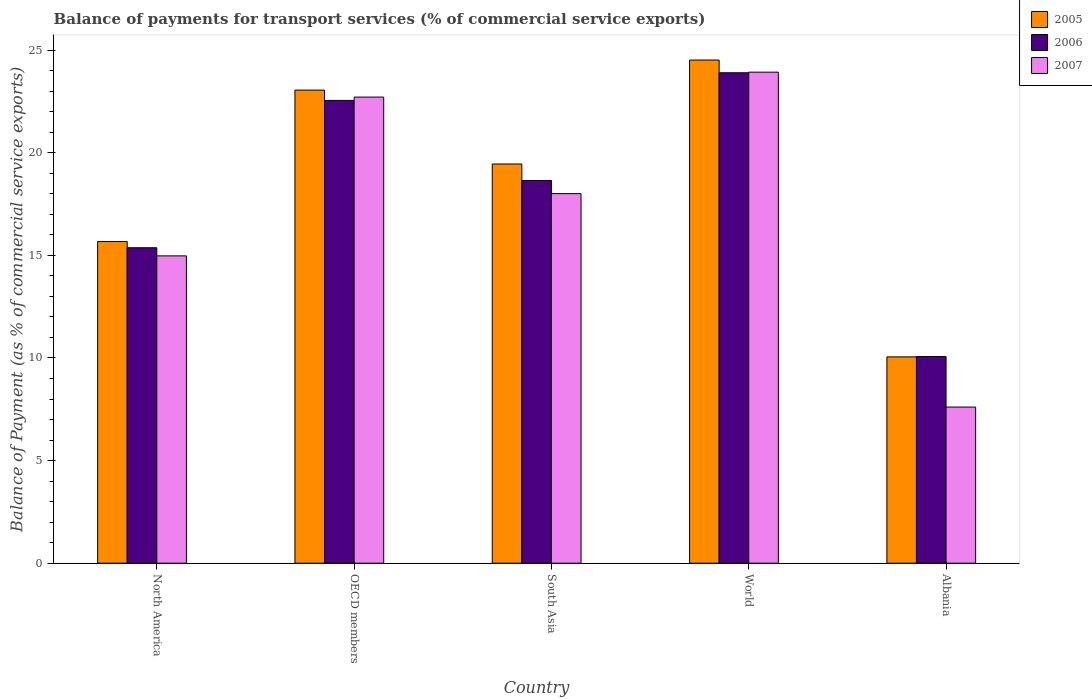Are the number of bars per tick equal to the number of legend labels?
Give a very brief answer. Yes. Are the number of bars on each tick of the X-axis equal?
Give a very brief answer. Yes. How many bars are there on the 3rd tick from the right?
Offer a very short reply. 3. In how many cases, is the number of bars for a given country not equal to the number of legend labels?
Keep it short and to the point. 0. What is the balance of payments for transport services in 2006 in Albania?
Ensure brevity in your answer.  10.07. Across all countries, what is the maximum balance of payments for transport services in 2005?
Provide a succinct answer. 24.52. Across all countries, what is the minimum balance of payments for transport services in 2006?
Your answer should be compact. 10.07. In which country was the balance of payments for transport services in 2007 maximum?
Give a very brief answer. World. In which country was the balance of payments for transport services in 2005 minimum?
Ensure brevity in your answer.  Albania. What is the total balance of payments for transport services in 2005 in the graph?
Keep it short and to the point. 92.75. What is the difference between the balance of payments for transport services in 2005 in North America and that in World?
Provide a succinct answer. -8.84. What is the difference between the balance of payments for transport services in 2006 in World and the balance of payments for transport services in 2007 in Albania?
Provide a succinct answer. 16.29. What is the average balance of payments for transport services in 2006 per country?
Offer a terse response. 18.11. What is the difference between the balance of payments for transport services of/in 2005 and balance of payments for transport services of/in 2006 in OECD members?
Your answer should be compact. 0.5. In how many countries, is the balance of payments for transport services in 2006 greater than 4 %?
Provide a short and direct response. 5. What is the ratio of the balance of payments for transport services in 2007 in OECD members to that in South Asia?
Your response must be concise. 1.26. Is the balance of payments for transport services in 2007 in North America less than that in World?
Your answer should be very brief. Yes. Is the difference between the balance of payments for transport services in 2005 in Albania and OECD members greater than the difference between the balance of payments for transport services in 2006 in Albania and OECD members?
Provide a short and direct response. No. What is the difference between the highest and the second highest balance of payments for transport services in 2006?
Your answer should be compact. -3.9. What is the difference between the highest and the lowest balance of payments for transport services in 2005?
Your answer should be compact. 14.46. In how many countries, is the balance of payments for transport services in 2007 greater than the average balance of payments for transport services in 2007 taken over all countries?
Offer a terse response. 3. Is the sum of the balance of payments for transport services in 2005 in Albania and OECD members greater than the maximum balance of payments for transport services in 2006 across all countries?
Your response must be concise. Yes. What does the 2nd bar from the right in Albania represents?
Provide a short and direct response. 2006. Are all the bars in the graph horizontal?
Offer a very short reply. No. What is the difference between two consecutive major ticks on the Y-axis?
Provide a short and direct response. 5. Are the values on the major ticks of Y-axis written in scientific E-notation?
Your response must be concise. No. Where does the legend appear in the graph?
Ensure brevity in your answer.  Top right. What is the title of the graph?
Offer a very short reply. Balance of payments for transport services (% of commercial service exports). Does "1987" appear as one of the legend labels in the graph?
Offer a terse response. No. What is the label or title of the Y-axis?
Offer a very short reply. Balance of Payment (as % of commercial service exports). What is the Balance of Payment (as % of commercial service exports) in 2005 in North America?
Keep it short and to the point. 15.67. What is the Balance of Payment (as % of commercial service exports) in 2006 in North America?
Ensure brevity in your answer.  15.37. What is the Balance of Payment (as % of commercial service exports) in 2007 in North America?
Ensure brevity in your answer.  14.97. What is the Balance of Payment (as % of commercial service exports) in 2005 in OECD members?
Your answer should be very brief. 23.05. What is the Balance of Payment (as % of commercial service exports) in 2006 in OECD members?
Provide a short and direct response. 22.55. What is the Balance of Payment (as % of commercial service exports) in 2007 in OECD members?
Offer a terse response. 22.71. What is the Balance of Payment (as % of commercial service exports) of 2005 in South Asia?
Your answer should be very brief. 19.45. What is the Balance of Payment (as % of commercial service exports) of 2006 in South Asia?
Your answer should be compact. 18.65. What is the Balance of Payment (as % of commercial service exports) of 2007 in South Asia?
Provide a succinct answer. 18.01. What is the Balance of Payment (as % of commercial service exports) of 2005 in World?
Provide a succinct answer. 24.52. What is the Balance of Payment (as % of commercial service exports) of 2006 in World?
Offer a very short reply. 23.9. What is the Balance of Payment (as % of commercial service exports) in 2007 in World?
Offer a very short reply. 23.93. What is the Balance of Payment (as % of commercial service exports) of 2005 in Albania?
Make the answer very short. 10.05. What is the Balance of Payment (as % of commercial service exports) of 2006 in Albania?
Ensure brevity in your answer.  10.07. What is the Balance of Payment (as % of commercial service exports) of 2007 in Albania?
Provide a succinct answer. 7.61. Across all countries, what is the maximum Balance of Payment (as % of commercial service exports) of 2005?
Keep it short and to the point. 24.52. Across all countries, what is the maximum Balance of Payment (as % of commercial service exports) in 2006?
Give a very brief answer. 23.9. Across all countries, what is the maximum Balance of Payment (as % of commercial service exports) in 2007?
Offer a terse response. 23.93. Across all countries, what is the minimum Balance of Payment (as % of commercial service exports) of 2005?
Keep it short and to the point. 10.05. Across all countries, what is the minimum Balance of Payment (as % of commercial service exports) in 2006?
Ensure brevity in your answer.  10.07. Across all countries, what is the minimum Balance of Payment (as % of commercial service exports) of 2007?
Your response must be concise. 7.61. What is the total Balance of Payment (as % of commercial service exports) of 2005 in the graph?
Your answer should be compact. 92.75. What is the total Balance of Payment (as % of commercial service exports) of 2006 in the graph?
Your answer should be very brief. 90.54. What is the total Balance of Payment (as % of commercial service exports) in 2007 in the graph?
Provide a succinct answer. 87.23. What is the difference between the Balance of Payment (as % of commercial service exports) in 2005 in North America and that in OECD members?
Your answer should be very brief. -7.38. What is the difference between the Balance of Payment (as % of commercial service exports) of 2006 in North America and that in OECD members?
Make the answer very short. -7.18. What is the difference between the Balance of Payment (as % of commercial service exports) in 2007 in North America and that in OECD members?
Ensure brevity in your answer.  -7.74. What is the difference between the Balance of Payment (as % of commercial service exports) of 2005 in North America and that in South Asia?
Your response must be concise. -3.78. What is the difference between the Balance of Payment (as % of commercial service exports) in 2006 in North America and that in South Asia?
Offer a terse response. -3.28. What is the difference between the Balance of Payment (as % of commercial service exports) in 2007 in North America and that in South Asia?
Your answer should be very brief. -3.03. What is the difference between the Balance of Payment (as % of commercial service exports) of 2005 in North America and that in World?
Keep it short and to the point. -8.84. What is the difference between the Balance of Payment (as % of commercial service exports) of 2006 in North America and that in World?
Provide a short and direct response. -8.53. What is the difference between the Balance of Payment (as % of commercial service exports) in 2007 in North America and that in World?
Your answer should be compact. -8.95. What is the difference between the Balance of Payment (as % of commercial service exports) of 2005 in North America and that in Albania?
Offer a very short reply. 5.62. What is the difference between the Balance of Payment (as % of commercial service exports) of 2006 in North America and that in Albania?
Make the answer very short. 5.3. What is the difference between the Balance of Payment (as % of commercial service exports) of 2007 in North America and that in Albania?
Provide a succinct answer. 7.37. What is the difference between the Balance of Payment (as % of commercial service exports) of 2005 in OECD members and that in South Asia?
Offer a terse response. 3.6. What is the difference between the Balance of Payment (as % of commercial service exports) of 2006 in OECD members and that in South Asia?
Ensure brevity in your answer.  3.9. What is the difference between the Balance of Payment (as % of commercial service exports) in 2007 in OECD members and that in South Asia?
Offer a terse response. 4.7. What is the difference between the Balance of Payment (as % of commercial service exports) in 2005 in OECD members and that in World?
Keep it short and to the point. -1.47. What is the difference between the Balance of Payment (as % of commercial service exports) in 2006 in OECD members and that in World?
Your response must be concise. -1.35. What is the difference between the Balance of Payment (as % of commercial service exports) in 2007 in OECD members and that in World?
Make the answer very short. -1.21. What is the difference between the Balance of Payment (as % of commercial service exports) in 2005 in OECD members and that in Albania?
Make the answer very short. 13. What is the difference between the Balance of Payment (as % of commercial service exports) of 2006 in OECD members and that in Albania?
Your answer should be compact. 12.48. What is the difference between the Balance of Payment (as % of commercial service exports) of 2007 in OECD members and that in Albania?
Give a very brief answer. 15.1. What is the difference between the Balance of Payment (as % of commercial service exports) of 2005 in South Asia and that in World?
Make the answer very short. -5.07. What is the difference between the Balance of Payment (as % of commercial service exports) of 2006 in South Asia and that in World?
Offer a very short reply. -5.25. What is the difference between the Balance of Payment (as % of commercial service exports) of 2007 in South Asia and that in World?
Offer a terse response. -5.92. What is the difference between the Balance of Payment (as % of commercial service exports) in 2005 in South Asia and that in Albania?
Offer a terse response. 9.4. What is the difference between the Balance of Payment (as % of commercial service exports) in 2006 in South Asia and that in Albania?
Keep it short and to the point. 8.58. What is the difference between the Balance of Payment (as % of commercial service exports) of 2007 in South Asia and that in Albania?
Your answer should be compact. 10.4. What is the difference between the Balance of Payment (as % of commercial service exports) in 2005 in World and that in Albania?
Your answer should be compact. 14.46. What is the difference between the Balance of Payment (as % of commercial service exports) of 2006 in World and that in Albania?
Make the answer very short. 13.83. What is the difference between the Balance of Payment (as % of commercial service exports) of 2007 in World and that in Albania?
Your answer should be very brief. 16.32. What is the difference between the Balance of Payment (as % of commercial service exports) in 2005 in North America and the Balance of Payment (as % of commercial service exports) in 2006 in OECD members?
Provide a short and direct response. -6.88. What is the difference between the Balance of Payment (as % of commercial service exports) of 2005 in North America and the Balance of Payment (as % of commercial service exports) of 2007 in OECD members?
Offer a very short reply. -7.04. What is the difference between the Balance of Payment (as % of commercial service exports) in 2006 in North America and the Balance of Payment (as % of commercial service exports) in 2007 in OECD members?
Your answer should be compact. -7.34. What is the difference between the Balance of Payment (as % of commercial service exports) in 2005 in North America and the Balance of Payment (as % of commercial service exports) in 2006 in South Asia?
Keep it short and to the point. -2.98. What is the difference between the Balance of Payment (as % of commercial service exports) in 2005 in North America and the Balance of Payment (as % of commercial service exports) in 2007 in South Asia?
Make the answer very short. -2.34. What is the difference between the Balance of Payment (as % of commercial service exports) in 2006 in North America and the Balance of Payment (as % of commercial service exports) in 2007 in South Asia?
Offer a terse response. -2.64. What is the difference between the Balance of Payment (as % of commercial service exports) in 2005 in North America and the Balance of Payment (as % of commercial service exports) in 2006 in World?
Make the answer very short. -8.22. What is the difference between the Balance of Payment (as % of commercial service exports) in 2005 in North America and the Balance of Payment (as % of commercial service exports) in 2007 in World?
Your answer should be very brief. -8.25. What is the difference between the Balance of Payment (as % of commercial service exports) in 2006 in North America and the Balance of Payment (as % of commercial service exports) in 2007 in World?
Provide a succinct answer. -8.56. What is the difference between the Balance of Payment (as % of commercial service exports) in 2005 in North America and the Balance of Payment (as % of commercial service exports) in 2006 in Albania?
Give a very brief answer. 5.6. What is the difference between the Balance of Payment (as % of commercial service exports) of 2005 in North America and the Balance of Payment (as % of commercial service exports) of 2007 in Albania?
Give a very brief answer. 8.06. What is the difference between the Balance of Payment (as % of commercial service exports) in 2006 in North America and the Balance of Payment (as % of commercial service exports) in 2007 in Albania?
Make the answer very short. 7.76. What is the difference between the Balance of Payment (as % of commercial service exports) of 2005 in OECD members and the Balance of Payment (as % of commercial service exports) of 2006 in South Asia?
Offer a terse response. 4.4. What is the difference between the Balance of Payment (as % of commercial service exports) in 2005 in OECD members and the Balance of Payment (as % of commercial service exports) in 2007 in South Asia?
Give a very brief answer. 5.04. What is the difference between the Balance of Payment (as % of commercial service exports) of 2006 in OECD members and the Balance of Payment (as % of commercial service exports) of 2007 in South Asia?
Make the answer very short. 4.54. What is the difference between the Balance of Payment (as % of commercial service exports) in 2005 in OECD members and the Balance of Payment (as % of commercial service exports) in 2006 in World?
Ensure brevity in your answer.  -0.85. What is the difference between the Balance of Payment (as % of commercial service exports) in 2005 in OECD members and the Balance of Payment (as % of commercial service exports) in 2007 in World?
Give a very brief answer. -0.87. What is the difference between the Balance of Payment (as % of commercial service exports) in 2006 in OECD members and the Balance of Payment (as % of commercial service exports) in 2007 in World?
Keep it short and to the point. -1.38. What is the difference between the Balance of Payment (as % of commercial service exports) in 2005 in OECD members and the Balance of Payment (as % of commercial service exports) in 2006 in Albania?
Your answer should be very brief. 12.98. What is the difference between the Balance of Payment (as % of commercial service exports) of 2005 in OECD members and the Balance of Payment (as % of commercial service exports) of 2007 in Albania?
Your answer should be very brief. 15.44. What is the difference between the Balance of Payment (as % of commercial service exports) of 2006 in OECD members and the Balance of Payment (as % of commercial service exports) of 2007 in Albania?
Offer a terse response. 14.94. What is the difference between the Balance of Payment (as % of commercial service exports) in 2005 in South Asia and the Balance of Payment (as % of commercial service exports) in 2006 in World?
Offer a very short reply. -4.45. What is the difference between the Balance of Payment (as % of commercial service exports) of 2005 in South Asia and the Balance of Payment (as % of commercial service exports) of 2007 in World?
Provide a short and direct response. -4.47. What is the difference between the Balance of Payment (as % of commercial service exports) in 2006 in South Asia and the Balance of Payment (as % of commercial service exports) in 2007 in World?
Your response must be concise. -5.28. What is the difference between the Balance of Payment (as % of commercial service exports) of 2005 in South Asia and the Balance of Payment (as % of commercial service exports) of 2006 in Albania?
Provide a succinct answer. 9.38. What is the difference between the Balance of Payment (as % of commercial service exports) in 2005 in South Asia and the Balance of Payment (as % of commercial service exports) in 2007 in Albania?
Give a very brief answer. 11.84. What is the difference between the Balance of Payment (as % of commercial service exports) of 2006 in South Asia and the Balance of Payment (as % of commercial service exports) of 2007 in Albania?
Your response must be concise. 11.04. What is the difference between the Balance of Payment (as % of commercial service exports) in 2005 in World and the Balance of Payment (as % of commercial service exports) in 2006 in Albania?
Offer a very short reply. 14.45. What is the difference between the Balance of Payment (as % of commercial service exports) in 2005 in World and the Balance of Payment (as % of commercial service exports) in 2007 in Albania?
Ensure brevity in your answer.  16.91. What is the difference between the Balance of Payment (as % of commercial service exports) in 2006 in World and the Balance of Payment (as % of commercial service exports) in 2007 in Albania?
Make the answer very short. 16.29. What is the average Balance of Payment (as % of commercial service exports) of 2005 per country?
Your response must be concise. 18.55. What is the average Balance of Payment (as % of commercial service exports) in 2006 per country?
Keep it short and to the point. 18.11. What is the average Balance of Payment (as % of commercial service exports) in 2007 per country?
Give a very brief answer. 17.45. What is the difference between the Balance of Payment (as % of commercial service exports) in 2005 and Balance of Payment (as % of commercial service exports) in 2006 in North America?
Make the answer very short. 0.3. What is the difference between the Balance of Payment (as % of commercial service exports) in 2005 and Balance of Payment (as % of commercial service exports) in 2007 in North America?
Provide a short and direct response. 0.7. What is the difference between the Balance of Payment (as % of commercial service exports) of 2006 and Balance of Payment (as % of commercial service exports) of 2007 in North America?
Your answer should be very brief. 0.4. What is the difference between the Balance of Payment (as % of commercial service exports) of 2005 and Balance of Payment (as % of commercial service exports) of 2006 in OECD members?
Ensure brevity in your answer.  0.5. What is the difference between the Balance of Payment (as % of commercial service exports) of 2005 and Balance of Payment (as % of commercial service exports) of 2007 in OECD members?
Provide a succinct answer. 0.34. What is the difference between the Balance of Payment (as % of commercial service exports) of 2006 and Balance of Payment (as % of commercial service exports) of 2007 in OECD members?
Your response must be concise. -0.16. What is the difference between the Balance of Payment (as % of commercial service exports) of 2005 and Balance of Payment (as % of commercial service exports) of 2006 in South Asia?
Your answer should be very brief. 0.8. What is the difference between the Balance of Payment (as % of commercial service exports) in 2005 and Balance of Payment (as % of commercial service exports) in 2007 in South Asia?
Provide a succinct answer. 1.44. What is the difference between the Balance of Payment (as % of commercial service exports) of 2006 and Balance of Payment (as % of commercial service exports) of 2007 in South Asia?
Provide a succinct answer. 0.64. What is the difference between the Balance of Payment (as % of commercial service exports) in 2005 and Balance of Payment (as % of commercial service exports) in 2006 in World?
Offer a very short reply. 0.62. What is the difference between the Balance of Payment (as % of commercial service exports) of 2005 and Balance of Payment (as % of commercial service exports) of 2007 in World?
Offer a very short reply. 0.59. What is the difference between the Balance of Payment (as % of commercial service exports) in 2006 and Balance of Payment (as % of commercial service exports) in 2007 in World?
Make the answer very short. -0.03. What is the difference between the Balance of Payment (as % of commercial service exports) of 2005 and Balance of Payment (as % of commercial service exports) of 2006 in Albania?
Your response must be concise. -0.02. What is the difference between the Balance of Payment (as % of commercial service exports) in 2005 and Balance of Payment (as % of commercial service exports) in 2007 in Albania?
Your answer should be compact. 2.44. What is the difference between the Balance of Payment (as % of commercial service exports) of 2006 and Balance of Payment (as % of commercial service exports) of 2007 in Albania?
Offer a terse response. 2.46. What is the ratio of the Balance of Payment (as % of commercial service exports) in 2005 in North America to that in OECD members?
Give a very brief answer. 0.68. What is the ratio of the Balance of Payment (as % of commercial service exports) in 2006 in North America to that in OECD members?
Provide a short and direct response. 0.68. What is the ratio of the Balance of Payment (as % of commercial service exports) of 2007 in North America to that in OECD members?
Your answer should be very brief. 0.66. What is the ratio of the Balance of Payment (as % of commercial service exports) in 2005 in North America to that in South Asia?
Offer a very short reply. 0.81. What is the ratio of the Balance of Payment (as % of commercial service exports) of 2006 in North America to that in South Asia?
Offer a very short reply. 0.82. What is the ratio of the Balance of Payment (as % of commercial service exports) in 2007 in North America to that in South Asia?
Provide a short and direct response. 0.83. What is the ratio of the Balance of Payment (as % of commercial service exports) of 2005 in North America to that in World?
Offer a very short reply. 0.64. What is the ratio of the Balance of Payment (as % of commercial service exports) of 2006 in North America to that in World?
Ensure brevity in your answer.  0.64. What is the ratio of the Balance of Payment (as % of commercial service exports) in 2007 in North America to that in World?
Your answer should be compact. 0.63. What is the ratio of the Balance of Payment (as % of commercial service exports) of 2005 in North America to that in Albania?
Offer a terse response. 1.56. What is the ratio of the Balance of Payment (as % of commercial service exports) in 2006 in North America to that in Albania?
Provide a short and direct response. 1.53. What is the ratio of the Balance of Payment (as % of commercial service exports) in 2007 in North America to that in Albania?
Provide a succinct answer. 1.97. What is the ratio of the Balance of Payment (as % of commercial service exports) of 2005 in OECD members to that in South Asia?
Your response must be concise. 1.19. What is the ratio of the Balance of Payment (as % of commercial service exports) in 2006 in OECD members to that in South Asia?
Make the answer very short. 1.21. What is the ratio of the Balance of Payment (as % of commercial service exports) in 2007 in OECD members to that in South Asia?
Provide a succinct answer. 1.26. What is the ratio of the Balance of Payment (as % of commercial service exports) of 2005 in OECD members to that in World?
Ensure brevity in your answer.  0.94. What is the ratio of the Balance of Payment (as % of commercial service exports) of 2006 in OECD members to that in World?
Offer a very short reply. 0.94. What is the ratio of the Balance of Payment (as % of commercial service exports) in 2007 in OECD members to that in World?
Your response must be concise. 0.95. What is the ratio of the Balance of Payment (as % of commercial service exports) of 2005 in OECD members to that in Albania?
Ensure brevity in your answer.  2.29. What is the ratio of the Balance of Payment (as % of commercial service exports) of 2006 in OECD members to that in Albania?
Your response must be concise. 2.24. What is the ratio of the Balance of Payment (as % of commercial service exports) of 2007 in OECD members to that in Albania?
Your answer should be compact. 2.98. What is the ratio of the Balance of Payment (as % of commercial service exports) in 2005 in South Asia to that in World?
Your answer should be very brief. 0.79. What is the ratio of the Balance of Payment (as % of commercial service exports) in 2006 in South Asia to that in World?
Make the answer very short. 0.78. What is the ratio of the Balance of Payment (as % of commercial service exports) in 2007 in South Asia to that in World?
Make the answer very short. 0.75. What is the ratio of the Balance of Payment (as % of commercial service exports) in 2005 in South Asia to that in Albania?
Your answer should be very brief. 1.94. What is the ratio of the Balance of Payment (as % of commercial service exports) of 2006 in South Asia to that in Albania?
Give a very brief answer. 1.85. What is the ratio of the Balance of Payment (as % of commercial service exports) in 2007 in South Asia to that in Albania?
Make the answer very short. 2.37. What is the ratio of the Balance of Payment (as % of commercial service exports) in 2005 in World to that in Albania?
Your response must be concise. 2.44. What is the ratio of the Balance of Payment (as % of commercial service exports) in 2006 in World to that in Albania?
Your response must be concise. 2.37. What is the ratio of the Balance of Payment (as % of commercial service exports) in 2007 in World to that in Albania?
Make the answer very short. 3.14. What is the difference between the highest and the second highest Balance of Payment (as % of commercial service exports) of 2005?
Offer a terse response. 1.47. What is the difference between the highest and the second highest Balance of Payment (as % of commercial service exports) of 2006?
Ensure brevity in your answer.  1.35. What is the difference between the highest and the second highest Balance of Payment (as % of commercial service exports) of 2007?
Offer a very short reply. 1.21. What is the difference between the highest and the lowest Balance of Payment (as % of commercial service exports) of 2005?
Give a very brief answer. 14.46. What is the difference between the highest and the lowest Balance of Payment (as % of commercial service exports) of 2006?
Your answer should be very brief. 13.83. What is the difference between the highest and the lowest Balance of Payment (as % of commercial service exports) of 2007?
Keep it short and to the point. 16.32. 